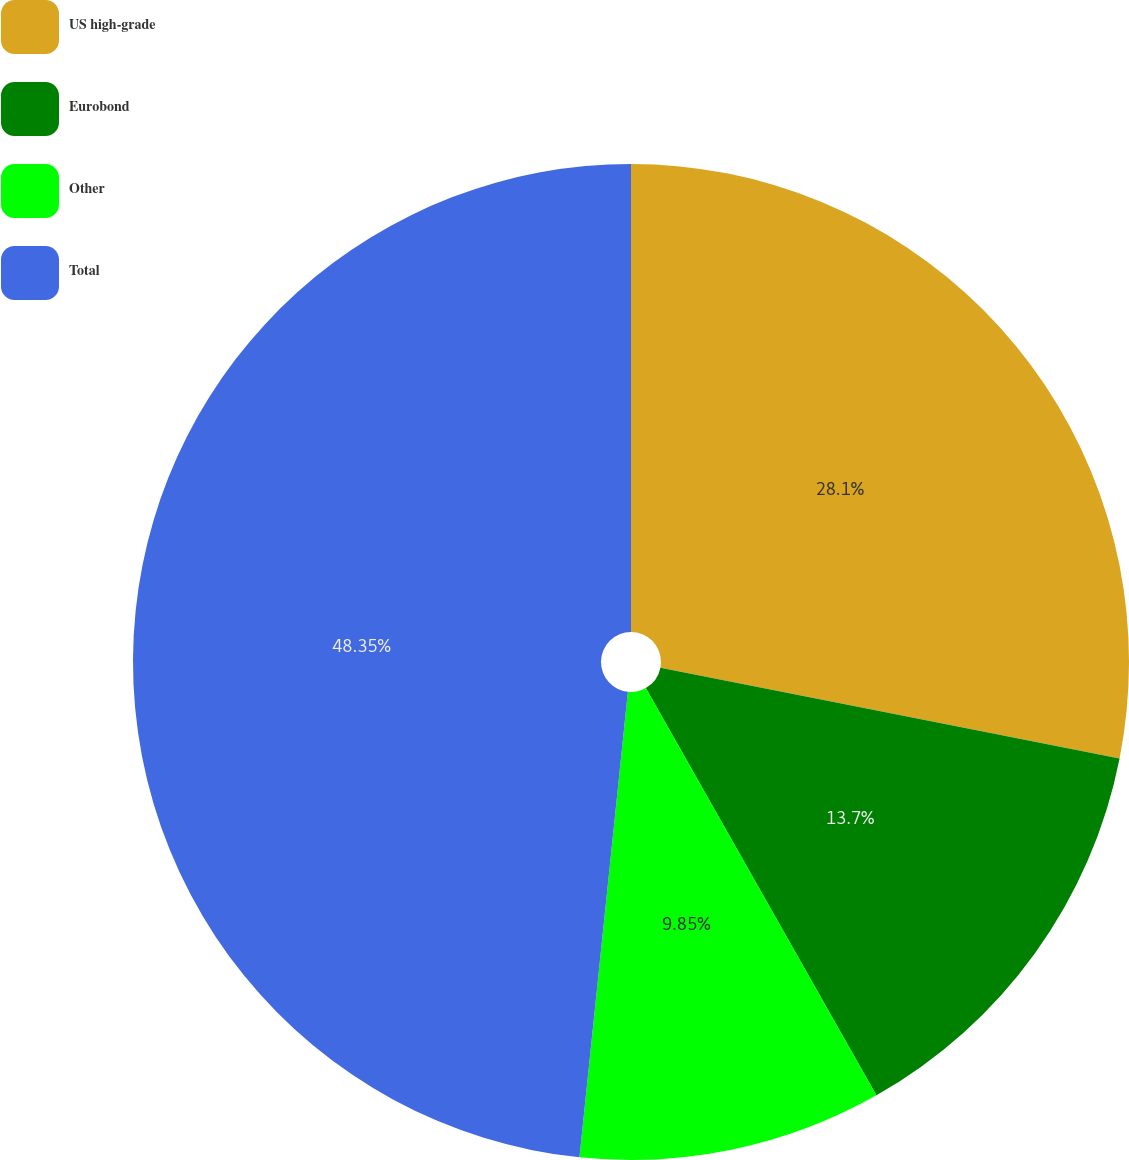Convert chart to OTSL. <chart><loc_0><loc_0><loc_500><loc_500><pie_chart><fcel>US high-grade<fcel>Eurobond<fcel>Other<fcel>Total<nl><fcel>28.1%<fcel>13.7%<fcel>9.85%<fcel>48.35%<nl></chart> 